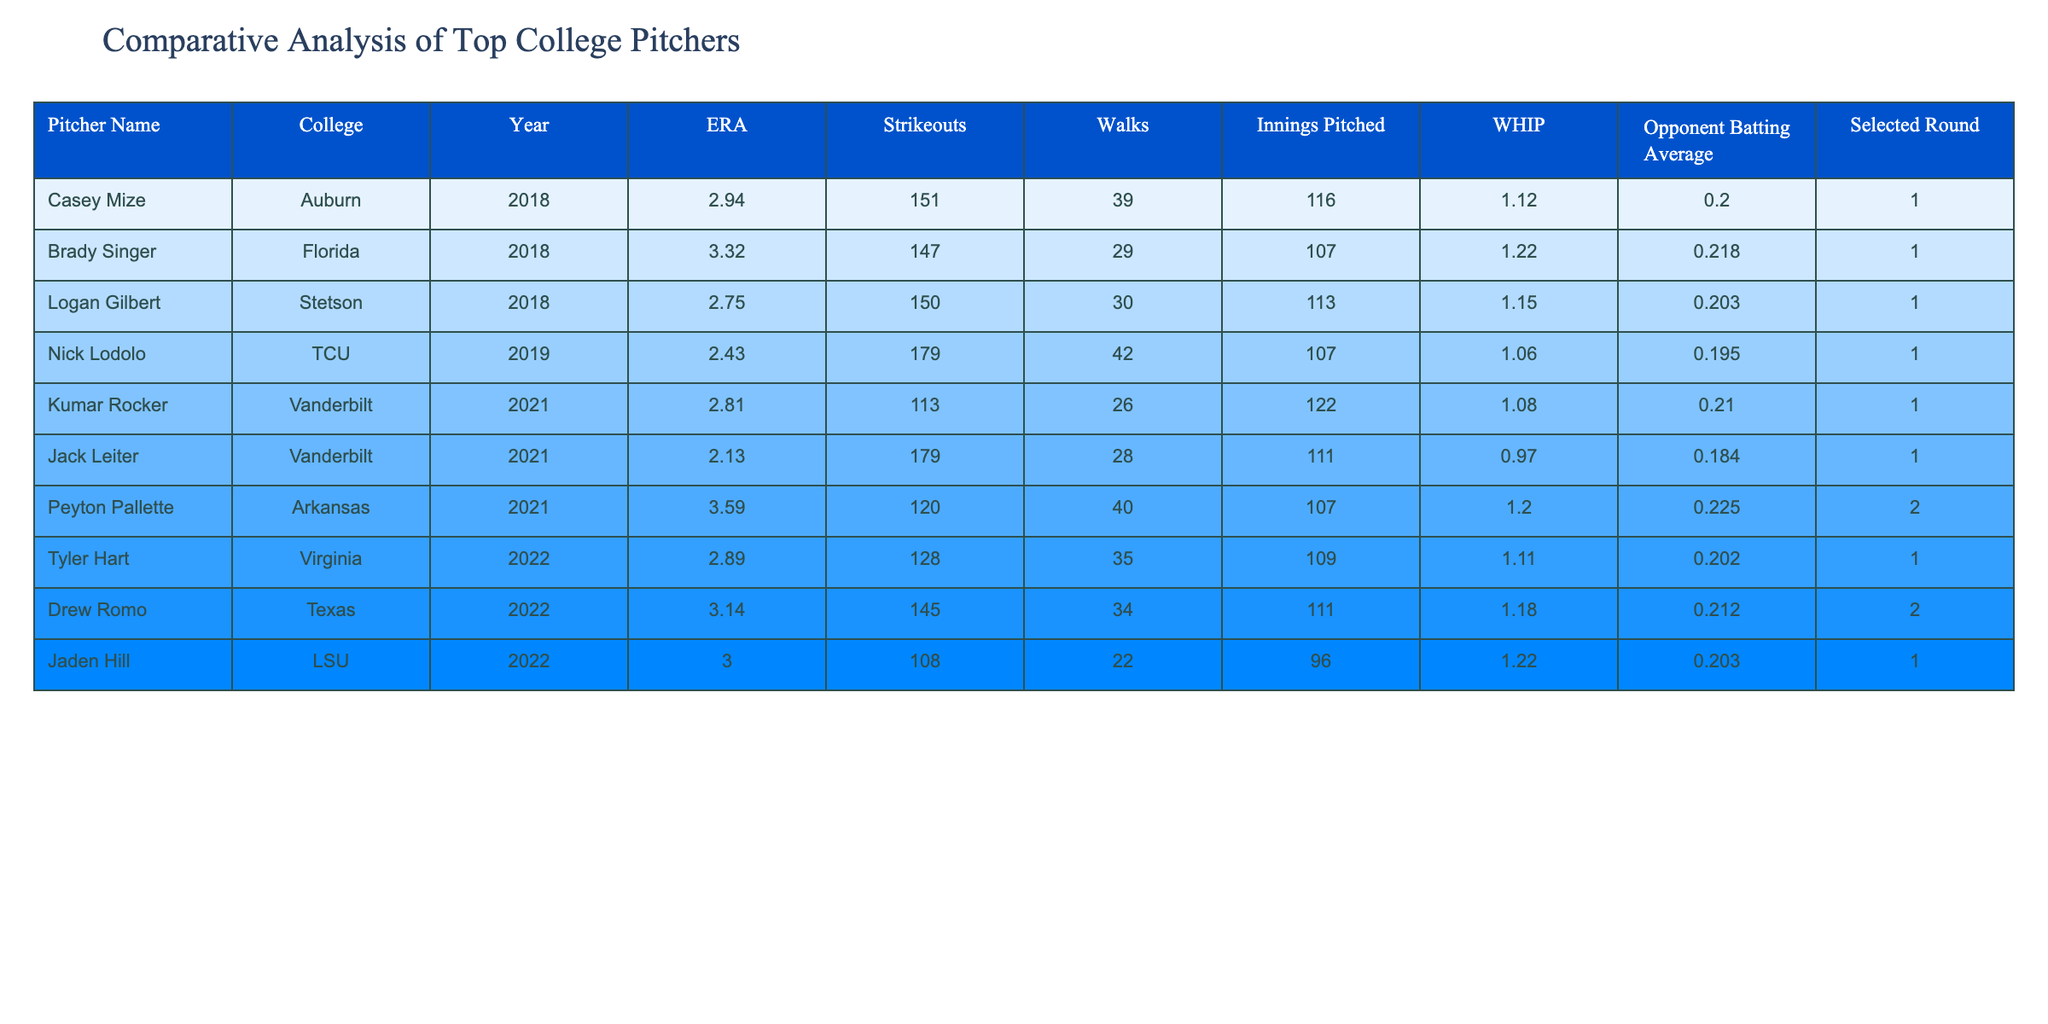What is the ERA of Nick Lodolo? Nick Lodolo's ERA can be found directly in the table under his name. He has an ERA of 2.43.
Answer: 2.43 What college did Casey Mize attend? The college associated with Casey Mize is listed in the corresponding row under the College column, which shows Auburn.
Answer: Auburn Which pitcher had the highest number of strikeouts? Looking at the Strikeouts column, Nick Lodolo has the highest number of strikeouts at 179, compared to all other pitchers listed.
Answer: 179 What is the average WHIP of all pitchers in the table? To find the average WHIP, add all the WHIP values together: (1.12 + 1.22 + 1.15 + 1.06 + 1.08 + 0.97 + 1.20 + 1.11 + 1.18 + 1.22) = 11.20. Then divide by the total number of pitchers (10): 11.20 / 10 = 1.12.
Answer: 1.12 Did Jack Leiter pitch more innings than Kumar Rocker? Under the Innings Pitched column, Jack Leiter pitched 111 innings, while Kumar Rocker pitched 122 innings. Since 111 is less than 122, the statement is false.
Answer: No Which pitcher had the lowest opponent batting average? Checking the Opponent Batting Average column, Jack Leiter has the lowest at .184 compared to others in the list.
Answer: .184 Is the Selected Round for Peyton Pallette greater than 1? The Selected Round for Peyton Pallette is 2 as seen in the table, which indicates he was selected in a later round. Therefore, the answer is true.
Answer: Yes What is the difference in ERA between the pitcher with the highest ERA and the one with the lowest? The highest ERA in the table is Peyton Pallette at 3.59, and the lowest is Nick Lodolo at 2.43. To find the difference, subtract: 3.59 - 2.43 = 1.16.
Answer: 1.16 Which pitcher from Arkansas has a higher ERA than 3.00? From the table, the only pitcher from Arkansas is Peyton Pallette who has an ERA of 3.59, which is higher than 3.00. This means the statement is true.
Answer: Yes 